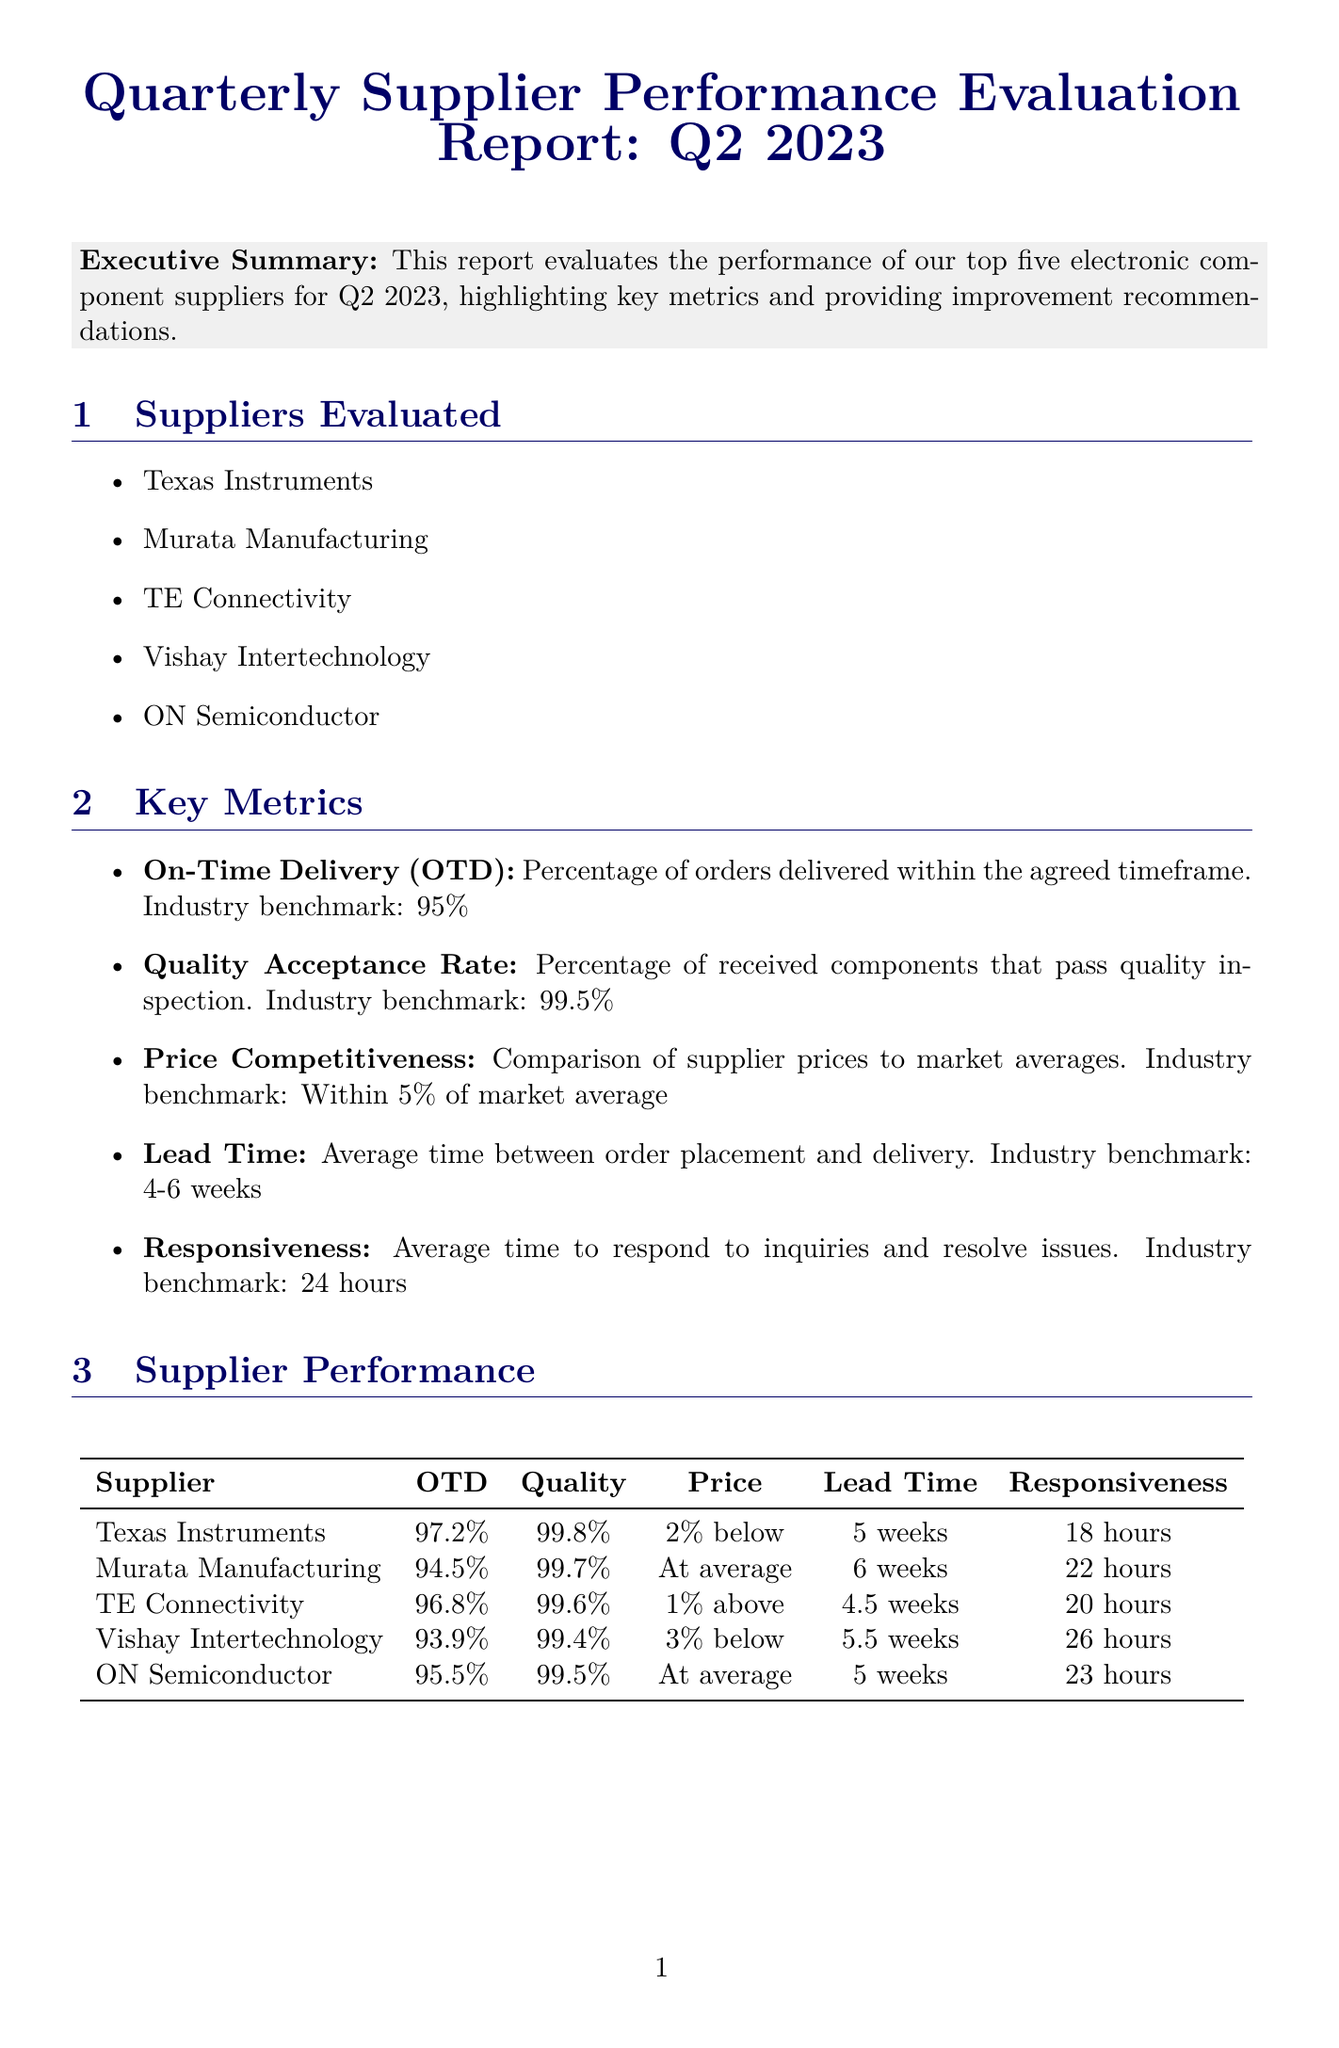What is the title of the report? The title of the report is specified in the document's heading section.
Answer: Quarterly Supplier Performance Evaluation Report: Q2 2023 Who had the highest On-Time Delivery percentage? The On-Time Delivery percentages for each supplier are compared in a table within the document.
Answer: Texas Instruments What is the industry benchmark for Quality Acceptance Rate? The document outlines the industry benchmarks in the Key Metrics section.
Answer: 99.5% Which supplier is recommended to establish a dedicated account management team? The improvement recommendations section specifies which supplier should undertake this action.
Answer: Vishay Intertechnology What is the average lead time benchmark? The key metrics section includes the benchmark for lead time.
Answer: 4-6 weeks Which supplier has a price competitiveness of 1% above market average? The supplier list includes their price competitiveness in the performance section.
Answer: TE Connectivity What is a current industry trend mentioned in the report? The report lists several industry trends, highlighting key factors affecting suppliers.
Answer: Increasing demand for automotive-grade components due to electric vehicle market growth What is the main conclusion of the report? The conclusion summarizes the overall findings about supplier performance in the document.
Answer: Suppliers have performed well this quarter, with Texas Instruments leading in most metrics 